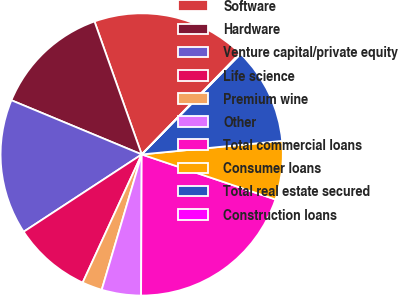<chart> <loc_0><loc_0><loc_500><loc_500><pie_chart><fcel>Software<fcel>Hardware<fcel>Venture capital/private equity<fcel>Life science<fcel>Premium wine<fcel>Other<fcel>Total commercial loans<fcel>Consumer loans<fcel>Total real estate secured<fcel>Construction loans<nl><fcel>17.7%<fcel>13.3%<fcel>15.5%<fcel>8.9%<fcel>2.3%<fcel>4.5%<fcel>19.9%<fcel>6.7%<fcel>11.1%<fcel>0.1%<nl></chart> 